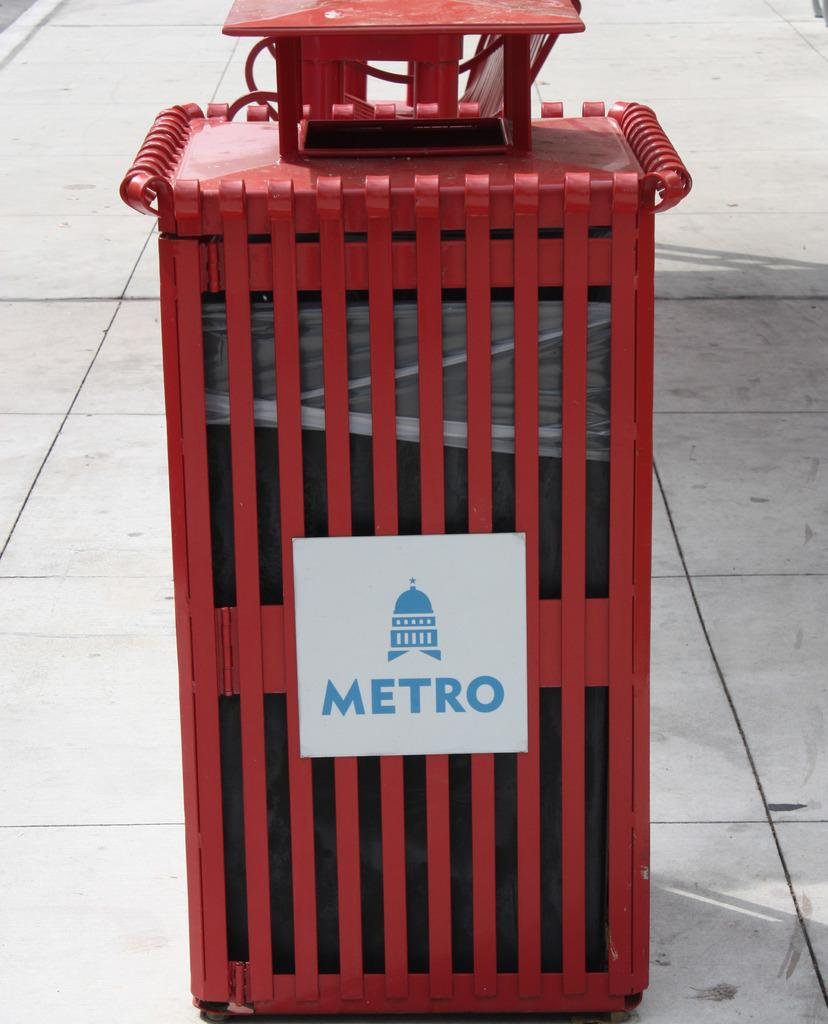What type of material is the object in the image made of? The object in the image is made of metal. Is there any writing or text on the metal object? Yes, there is text on the metal object. How does the ball bounce on the metal object in the image? There is no ball present in the image, so it cannot be determined how it would bounce on the metal object. 